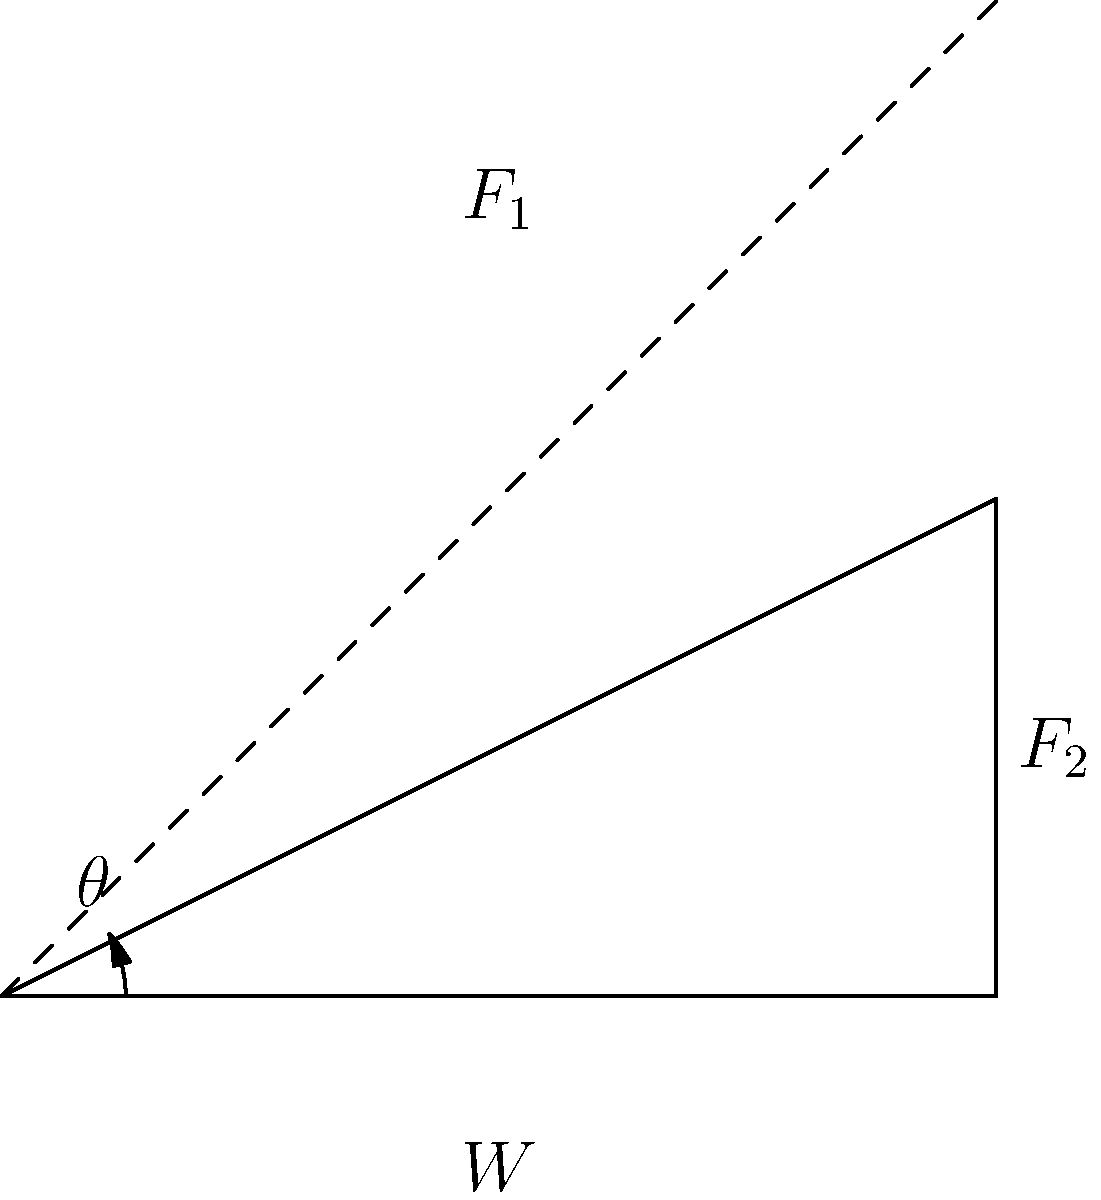During a protest in 1970s Italy, demonstrators used a simple inclined plane to move heavy objects. In the force diagram shown, which represents this scenario, what is the relationship between the force $F_1$ parallel to the inclined plane and the weight $W$ of the object, given a frictionless surface and an angle $\theta$ of 30°? To solve this problem, we'll follow these steps:

1. Identify the forces acting on the object:
   - Weight ($W$) acting vertically downward
   - Normal force ($N$) perpendicular to the inclined plane
   - Force $F_1$ parallel to the inclined plane

2. Resolve the weight vector into components parallel and perpendicular to the inclined plane:
   - Parallel component: $W \sin(\theta)$
   - Perpendicular component: $W \cos(\theta)$

3. For equilibrium on a frictionless surface, $F_1$ must be equal to the parallel component of the weight:
   $F_1 = W \sin(\theta)$

4. Given $\theta = 30°$, we can simplify:
   $F_1 = W \sin(30°) = W \cdot \frac{1}{2}$

5. Therefore, the relationship between $F_1$ and $W$ is:
   $F_1 = \frac{1}{2}W$

This relationship shows that the force required to keep the object stationary on the inclined plane is half of its weight.
Answer: $F_1 = \frac{1}{2}W$ 